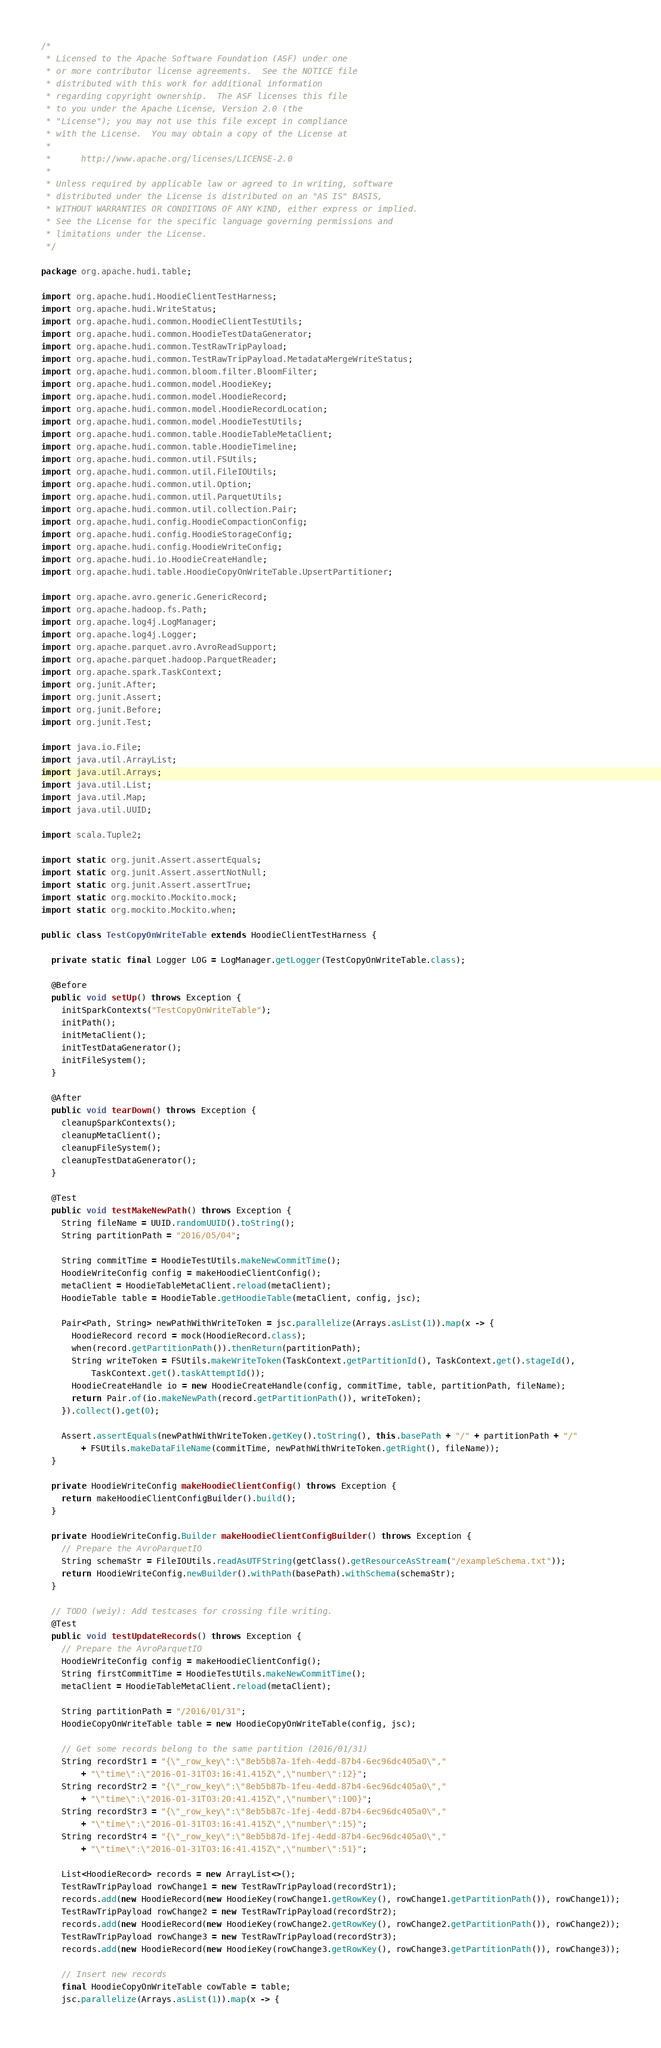Convert code to text. <code><loc_0><loc_0><loc_500><loc_500><_Java_>/*
 * Licensed to the Apache Software Foundation (ASF) under one
 * or more contributor license agreements.  See the NOTICE file
 * distributed with this work for additional information
 * regarding copyright ownership.  The ASF licenses this file
 * to you under the Apache License, Version 2.0 (the
 * "License"); you may not use this file except in compliance
 * with the License.  You may obtain a copy of the License at
 *
 *      http://www.apache.org/licenses/LICENSE-2.0
 *
 * Unless required by applicable law or agreed to in writing, software
 * distributed under the License is distributed on an "AS IS" BASIS,
 * WITHOUT WARRANTIES OR CONDITIONS OF ANY KIND, either express or implied.
 * See the License for the specific language governing permissions and
 * limitations under the License.
 */

package org.apache.hudi.table;

import org.apache.hudi.HoodieClientTestHarness;
import org.apache.hudi.WriteStatus;
import org.apache.hudi.common.HoodieClientTestUtils;
import org.apache.hudi.common.HoodieTestDataGenerator;
import org.apache.hudi.common.TestRawTripPayload;
import org.apache.hudi.common.TestRawTripPayload.MetadataMergeWriteStatus;
import org.apache.hudi.common.bloom.filter.BloomFilter;
import org.apache.hudi.common.model.HoodieKey;
import org.apache.hudi.common.model.HoodieRecord;
import org.apache.hudi.common.model.HoodieRecordLocation;
import org.apache.hudi.common.model.HoodieTestUtils;
import org.apache.hudi.common.table.HoodieTableMetaClient;
import org.apache.hudi.common.table.HoodieTimeline;
import org.apache.hudi.common.util.FSUtils;
import org.apache.hudi.common.util.FileIOUtils;
import org.apache.hudi.common.util.Option;
import org.apache.hudi.common.util.ParquetUtils;
import org.apache.hudi.common.util.collection.Pair;
import org.apache.hudi.config.HoodieCompactionConfig;
import org.apache.hudi.config.HoodieStorageConfig;
import org.apache.hudi.config.HoodieWriteConfig;
import org.apache.hudi.io.HoodieCreateHandle;
import org.apache.hudi.table.HoodieCopyOnWriteTable.UpsertPartitioner;

import org.apache.avro.generic.GenericRecord;
import org.apache.hadoop.fs.Path;
import org.apache.log4j.LogManager;
import org.apache.log4j.Logger;
import org.apache.parquet.avro.AvroReadSupport;
import org.apache.parquet.hadoop.ParquetReader;
import org.apache.spark.TaskContext;
import org.junit.After;
import org.junit.Assert;
import org.junit.Before;
import org.junit.Test;

import java.io.File;
import java.util.ArrayList;
import java.util.Arrays;
import java.util.List;
import java.util.Map;
import java.util.UUID;

import scala.Tuple2;

import static org.junit.Assert.assertEquals;
import static org.junit.Assert.assertNotNull;
import static org.junit.Assert.assertTrue;
import static org.mockito.Mockito.mock;
import static org.mockito.Mockito.when;

public class TestCopyOnWriteTable extends HoodieClientTestHarness {

  private static final Logger LOG = LogManager.getLogger(TestCopyOnWriteTable.class);

  @Before
  public void setUp() throws Exception {
    initSparkContexts("TestCopyOnWriteTable");
    initPath();
    initMetaClient();
    initTestDataGenerator();
    initFileSystem();
  }

  @After
  public void tearDown() throws Exception {
    cleanupSparkContexts();
    cleanupMetaClient();
    cleanupFileSystem();
    cleanupTestDataGenerator();
  }

  @Test
  public void testMakeNewPath() throws Exception {
    String fileName = UUID.randomUUID().toString();
    String partitionPath = "2016/05/04";

    String commitTime = HoodieTestUtils.makeNewCommitTime();
    HoodieWriteConfig config = makeHoodieClientConfig();
    metaClient = HoodieTableMetaClient.reload(metaClient);
    HoodieTable table = HoodieTable.getHoodieTable(metaClient, config, jsc);

    Pair<Path, String> newPathWithWriteToken = jsc.parallelize(Arrays.asList(1)).map(x -> {
      HoodieRecord record = mock(HoodieRecord.class);
      when(record.getPartitionPath()).thenReturn(partitionPath);
      String writeToken = FSUtils.makeWriteToken(TaskContext.getPartitionId(), TaskContext.get().stageId(),
          TaskContext.get().taskAttemptId());
      HoodieCreateHandle io = new HoodieCreateHandle(config, commitTime, table, partitionPath, fileName);
      return Pair.of(io.makeNewPath(record.getPartitionPath()), writeToken);
    }).collect().get(0);

    Assert.assertEquals(newPathWithWriteToken.getKey().toString(), this.basePath + "/" + partitionPath + "/"
        + FSUtils.makeDataFileName(commitTime, newPathWithWriteToken.getRight(), fileName));
  }

  private HoodieWriteConfig makeHoodieClientConfig() throws Exception {
    return makeHoodieClientConfigBuilder().build();
  }

  private HoodieWriteConfig.Builder makeHoodieClientConfigBuilder() throws Exception {
    // Prepare the AvroParquetIO
    String schemaStr = FileIOUtils.readAsUTFString(getClass().getResourceAsStream("/exampleSchema.txt"));
    return HoodieWriteConfig.newBuilder().withPath(basePath).withSchema(schemaStr);
  }

  // TODO (weiy): Add testcases for crossing file writing.
  @Test
  public void testUpdateRecords() throws Exception {
    // Prepare the AvroParquetIO
    HoodieWriteConfig config = makeHoodieClientConfig();
    String firstCommitTime = HoodieTestUtils.makeNewCommitTime();
    metaClient = HoodieTableMetaClient.reload(metaClient);

    String partitionPath = "/2016/01/31";
    HoodieCopyOnWriteTable table = new HoodieCopyOnWriteTable(config, jsc);

    // Get some records belong to the same partition (2016/01/31)
    String recordStr1 = "{\"_row_key\":\"8eb5b87a-1feh-4edd-87b4-6ec96dc405a0\","
        + "\"time\":\"2016-01-31T03:16:41.415Z\",\"number\":12}";
    String recordStr2 = "{\"_row_key\":\"8eb5b87b-1feu-4edd-87b4-6ec96dc405a0\","
        + "\"time\":\"2016-01-31T03:20:41.415Z\",\"number\":100}";
    String recordStr3 = "{\"_row_key\":\"8eb5b87c-1fej-4edd-87b4-6ec96dc405a0\","
        + "\"time\":\"2016-01-31T03:16:41.415Z\",\"number\":15}";
    String recordStr4 = "{\"_row_key\":\"8eb5b87d-1fej-4edd-87b4-6ec96dc405a0\","
        + "\"time\":\"2016-01-31T03:16:41.415Z\",\"number\":51}";

    List<HoodieRecord> records = new ArrayList<>();
    TestRawTripPayload rowChange1 = new TestRawTripPayload(recordStr1);
    records.add(new HoodieRecord(new HoodieKey(rowChange1.getRowKey(), rowChange1.getPartitionPath()), rowChange1));
    TestRawTripPayload rowChange2 = new TestRawTripPayload(recordStr2);
    records.add(new HoodieRecord(new HoodieKey(rowChange2.getRowKey(), rowChange2.getPartitionPath()), rowChange2));
    TestRawTripPayload rowChange3 = new TestRawTripPayload(recordStr3);
    records.add(new HoodieRecord(new HoodieKey(rowChange3.getRowKey(), rowChange3.getPartitionPath()), rowChange3));

    // Insert new records
    final HoodieCopyOnWriteTable cowTable = table;
    jsc.parallelize(Arrays.asList(1)).map(x -> {</code> 